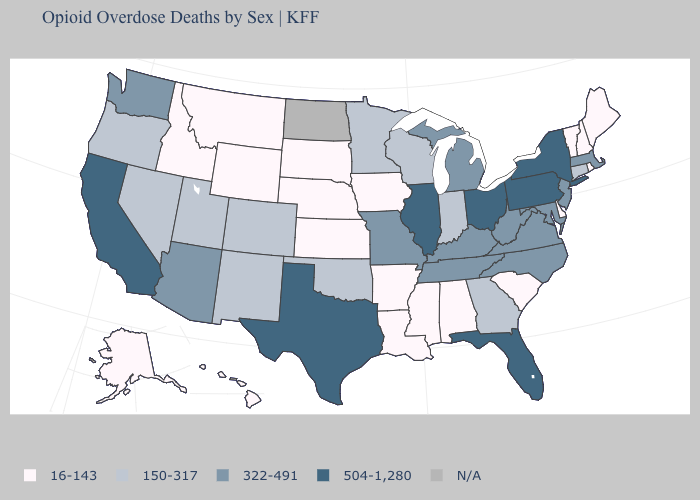What is the value of North Carolina?
Short answer required. 322-491. Does Utah have the highest value in the West?
Concise answer only. No. Which states have the lowest value in the MidWest?
Quick response, please. Iowa, Kansas, Nebraska, South Dakota. Name the states that have a value in the range 16-143?
Concise answer only. Alabama, Alaska, Arkansas, Delaware, Hawaii, Idaho, Iowa, Kansas, Louisiana, Maine, Mississippi, Montana, Nebraska, New Hampshire, Rhode Island, South Carolina, South Dakota, Vermont, Wyoming. Name the states that have a value in the range 16-143?
Be succinct. Alabama, Alaska, Arkansas, Delaware, Hawaii, Idaho, Iowa, Kansas, Louisiana, Maine, Mississippi, Montana, Nebraska, New Hampshire, Rhode Island, South Carolina, South Dakota, Vermont, Wyoming. Among the states that border Nebraska , does Kansas have the highest value?
Keep it brief. No. What is the lowest value in the USA?
Give a very brief answer. 16-143. Name the states that have a value in the range 150-317?
Answer briefly. Colorado, Connecticut, Georgia, Indiana, Minnesota, Nevada, New Mexico, Oklahoma, Oregon, Utah, Wisconsin. What is the value of Louisiana?
Quick response, please. 16-143. Which states have the lowest value in the USA?
Be succinct. Alabama, Alaska, Arkansas, Delaware, Hawaii, Idaho, Iowa, Kansas, Louisiana, Maine, Mississippi, Montana, Nebraska, New Hampshire, Rhode Island, South Carolina, South Dakota, Vermont, Wyoming. What is the highest value in the USA?
Quick response, please. 504-1,280. Name the states that have a value in the range 150-317?
Short answer required. Colorado, Connecticut, Georgia, Indiana, Minnesota, Nevada, New Mexico, Oklahoma, Oregon, Utah, Wisconsin. Name the states that have a value in the range 16-143?
Be succinct. Alabama, Alaska, Arkansas, Delaware, Hawaii, Idaho, Iowa, Kansas, Louisiana, Maine, Mississippi, Montana, Nebraska, New Hampshire, Rhode Island, South Carolina, South Dakota, Vermont, Wyoming. What is the value of Alabama?
Concise answer only. 16-143. What is the value of Arizona?
Concise answer only. 322-491. 